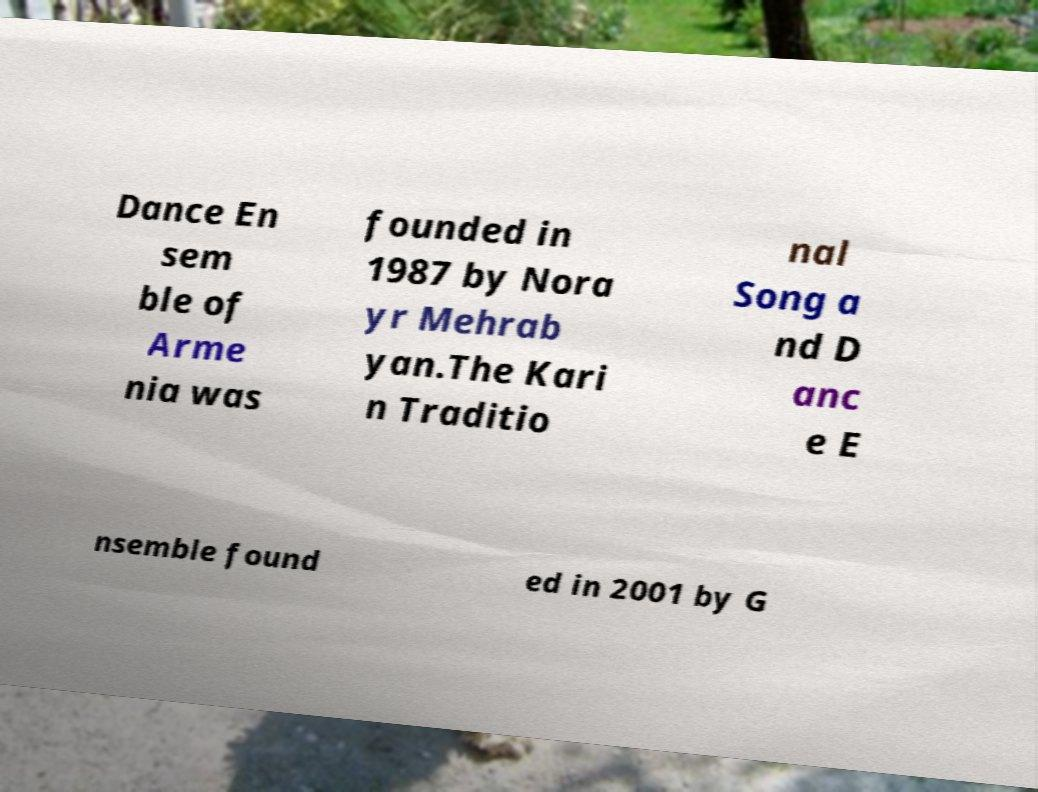Can you accurately transcribe the text from the provided image for me? Dance En sem ble of Arme nia was founded in 1987 by Nora yr Mehrab yan.The Kari n Traditio nal Song a nd D anc e E nsemble found ed in 2001 by G 